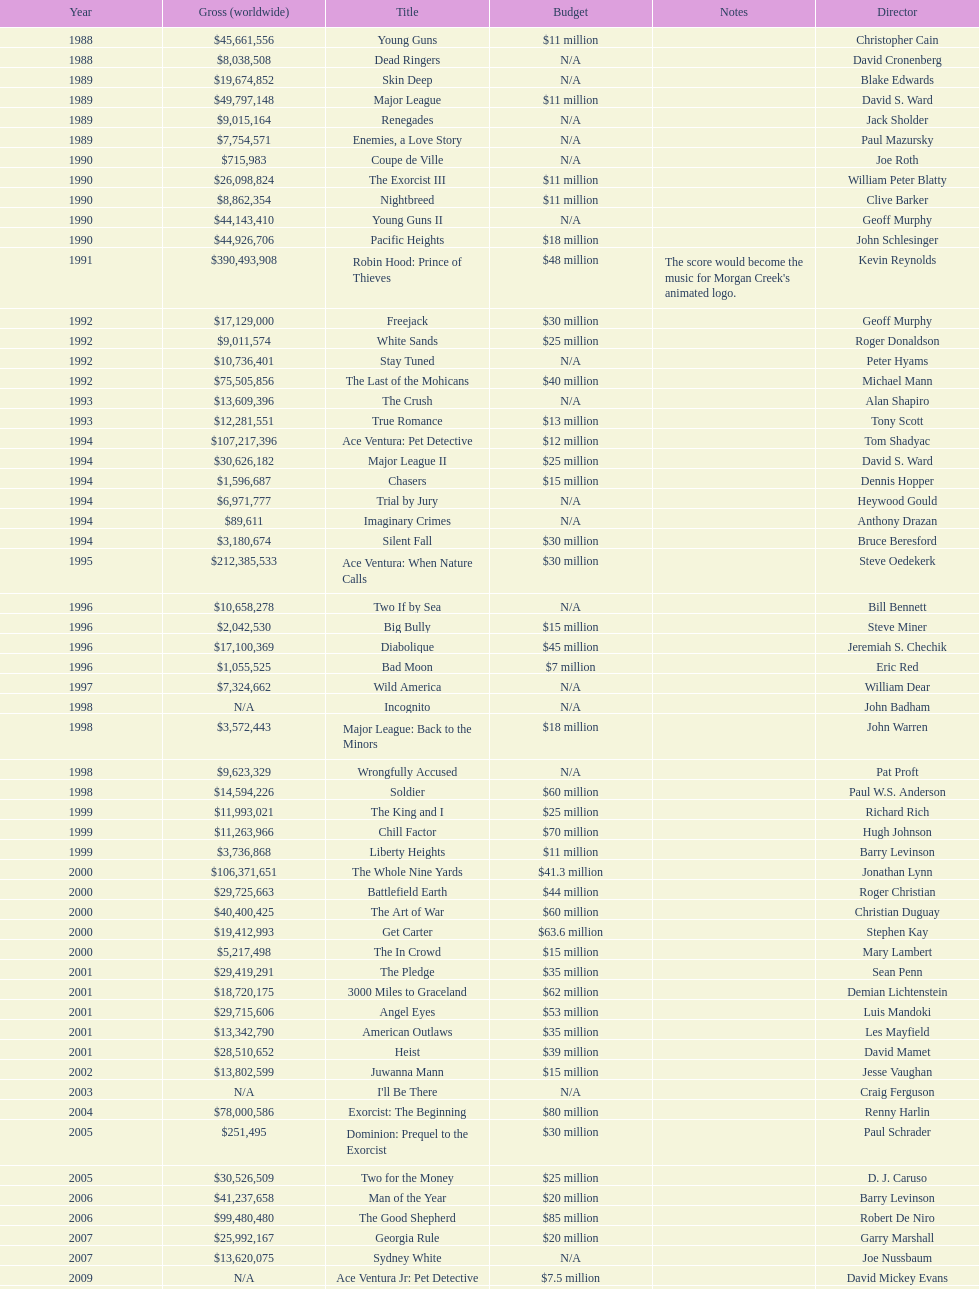Give me the full table as a dictionary. {'header': ['Year', 'Gross (worldwide)', 'Title', 'Budget', 'Notes', 'Director'], 'rows': [['1988', '$45,661,556', 'Young Guns', '$11 million', '', 'Christopher Cain'], ['1988', '$8,038,508', 'Dead Ringers', 'N/A', '', 'David Cronenberg'], ['1989', '$19,674,852', 'Skin Deep', 'N/A', '', 'Blake Edwards'], ['1989', '$49,797,148', 'Major League', '$11 million', '', 'David S. Ward'], ['1989', '$9,015,164', 'Renegades', 'N/A', '', 'Jack Sholder'], ['1989', '$7,754,571', 'Enemies, a Love Story', 'N/A', '', 'Paul Mazursky'], ['1990', '$715,983', 'Coupe de Ville', 'N/A', '', 'Joe Roth'], ['1990', '$26,098,824', 'The Exorcist III', '$11 million', '', 'William Peter Blatty'], ['1990', '$8,862,354', 'Nightbreed', '$11 million', '', 'Clive Barker'], ['1990', '$44,143,410', 'Young Guns II', 'N/A', '', 'Geoff Murphy'], ['1990', '$44,926,706', 'Pacific Heights', '$18 million', '', 'John Schlesinger'], ['1991', '$390,493,908', 'Robin Hood: Prince of Thieves', '$48 million', "The score would become the music for Morgan Creek's animated logo.", 'Kevin Reynolds'], ['1992', '$17,129,000', 'Freejack', '$30 million', '', 'Geoff Murphy'], ['1992', '$9,011,574', 'White Sands', '$25 million', '', 'Roger Donaldson'], ['1992', '$10,736,401', 'Stay Tuned', 'N/A', '', 'Peter Hyams'], ['1992', '$75,505,856', 'The Last of the Mohicans', '$40 million', '', 'Michael Mann'], ['1993', '$13,609,396', 'The Crush', 'N/A', '', 'Alan Shapiro'], ['1993', '$12,281,551', 'True Romance', '$13 million', '', 'Tony Scott'], ['1994', '$107,217,396', 'Ace Ventura: Pet Detective', '$12 million', '', 'Tom Shadyac'], ['1994', '$30,626,182', 'Major League II', '$25 million', '', 'David S. Ward'], ['1994', '$1,596,687', 'Chasers', '$15 million', '', 'Dennis Hopper'], ['1994', '$6,971,777', 'Trial by Jury', 'N/A', '', 'Heywood Gould'], ['1994', '$89,611', 'Imaginary Crimes', 'N/A', '', 'Anthony Drazan'], ['1994', '$3,180,674', 'Silent Fall', '$30 million', '', 'Bruce Beresford'], ['1995', '$212,385,533', 'Ace Ventura: When Nature Calls', '$30 million', '', 'Steve Oedekerk'], ['1996', '$10,658,278', 'Two If by Sea', 'N/A', '', 'Bill Bennett'], ['1996', '$2,042,530', 'Big Bully', '$15 million', '', 'Steve Miner'], ['1996', '$17,100,369', 'Diabolique', '$45 million', '', 'Jeremiah S. Chechik'], ['1996', '$1,055,525', 'Bad Moon', '$7 million', '', 'Eric Red'], ['1997', '$7,324,662', 'Wild America', 'N/A', '', 'William Dear'], ['1998', 'N/A', 'Incognito', 'N/A', '', 'John Badham'], ['1998', '$3,572,443', 'Major League: Back to the Minors', '$18 million', '', 'John Warren'], ['1998', '$9,623,329', 'Wrongfully Accused', 'N/A', '', 'Pat Proft'], ['1998', '$14,594,226', 'Soldier', '$60 million', '', 'Paul W.S. Anderson'], ['1999', '$11,993,021', 'The King and I', '$25 million', '', 'Richard Rich'], ['1999', '$11,263,966', 'Chill Factor', '$70 million', '', 'Hugh Johnson'], ['1999', '$3,736,868', 'Liberty Heights', '$11 million', '', 'Barry Levinson'], ['2000', '$106,371,651', 'The Whole Nine Yards', '$41.3 million', '', 'Jonathan Lynn'], ['2000', '$29,725,663', 'Battlefield Earth', '$44 million', '', 'Roger Christian'], ['2000', '$40,400,425', 'The Art of War', '$60 million', '', 'Christian Duguay'], ['2000', '$19,412,993', 'Get Carter', '$63.6 million', '', 'Stephen Kay'], ['2000', '$5,217,498', 'The In Crowd', '$15 million', '', 'Mary Lambert'], ['2001', '$29,419,291', 'The Pledge', '$35 million', '', 'Sean Penn'], ['2001', '$18,720,175', '3000 Miles to Graceland', '$62 million', '', 'Demian Lichtenstein'], ['2001', '$29,715,606', 'Angel Eyes', '$53 million', '', 'Luis Mandoki'], ['2001', '$13,342,790', 'American Outlaws', '$35 million', '', 'Les Mayfield'], ['2001', '$28,510,652', 'Heist', '$39 million', '', 'David Mamet'], ['2002', '$13,802,599', 'Juwanna Mann', '$15 million', '', 'Jesse Vaughan'], ['2003', 'N/A', "I'll Be There", 'N/A', '', 'Craig Ferguson'], ['2004', '$78,000,586', 'Exorcist: The Beginning', '$80 million', '', 'Renny Harlin'], ['2005', '$251,495', 'Dominion: Prequel to the Exorcist', '$30 million', '', 'Paul Schrader'], ['2005', '$30,526,509', 'Two for the Money', '$25 million', '', 'D. J. Caruso'], ['2006', '$41,237,658', 'Man of the Year', '$20 million', '', 'Barry Levinson'], ['2006', '$99,480,480', 'The Good Shepherd', '$85 million', '', 'Robert De Niro'], ['2007', '$25,992,167', 'Georgia Rule', '$20 million', '', 'Garry Marshall'], ['2007', '$13,620,075', 'Sydney White', 'N/A', '', 'Joe Nussbaum'], ['2009', 'N/A', 'Ace Ventura Jr: Pet Detective', '$7.5 million', '', 'David Mickey Evans'], ['2011', '$38,502,340', 'Dream House', '$50 million', '', 'Jim Sheridan'], ['2011', '$27,428,670', 'The Thing', '$38 million', '', 'Matthijs van Heijningen Jr.'], ['2014', '', 'Tupac', '$45 million', '', 'Antoine Fuqua']]} What is the number of films directed by david s. ward? 2. 